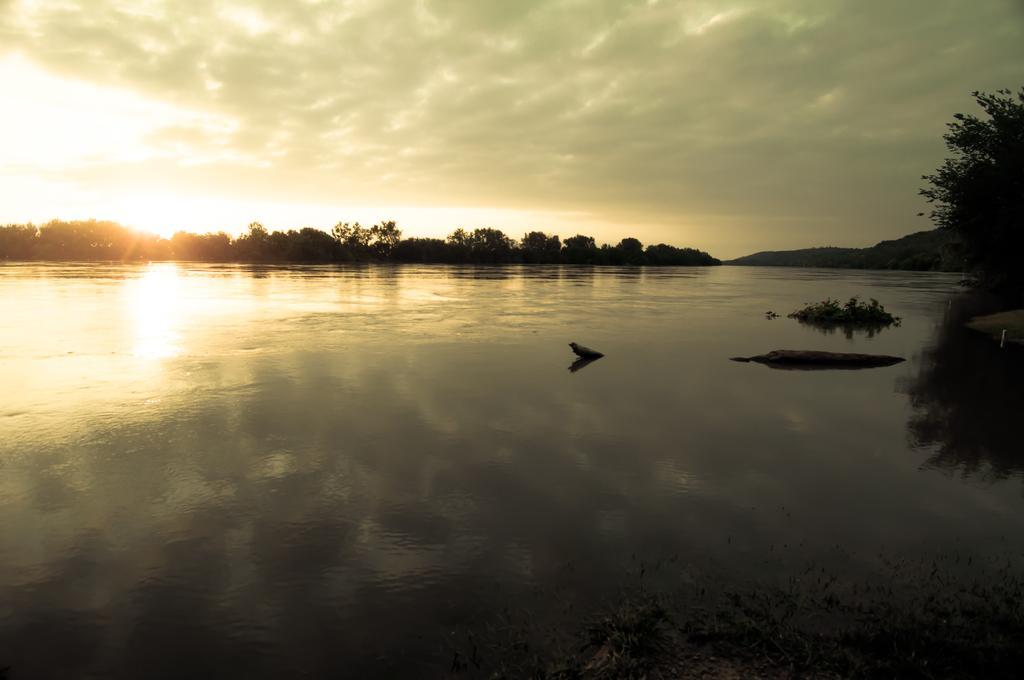Can you describe this image briefly? In this image at the bottom there is a river, and in the background there are some trees and mountains. At the top of the image there is sky and in the water there are some plants, at the bottom also there are some plants. 